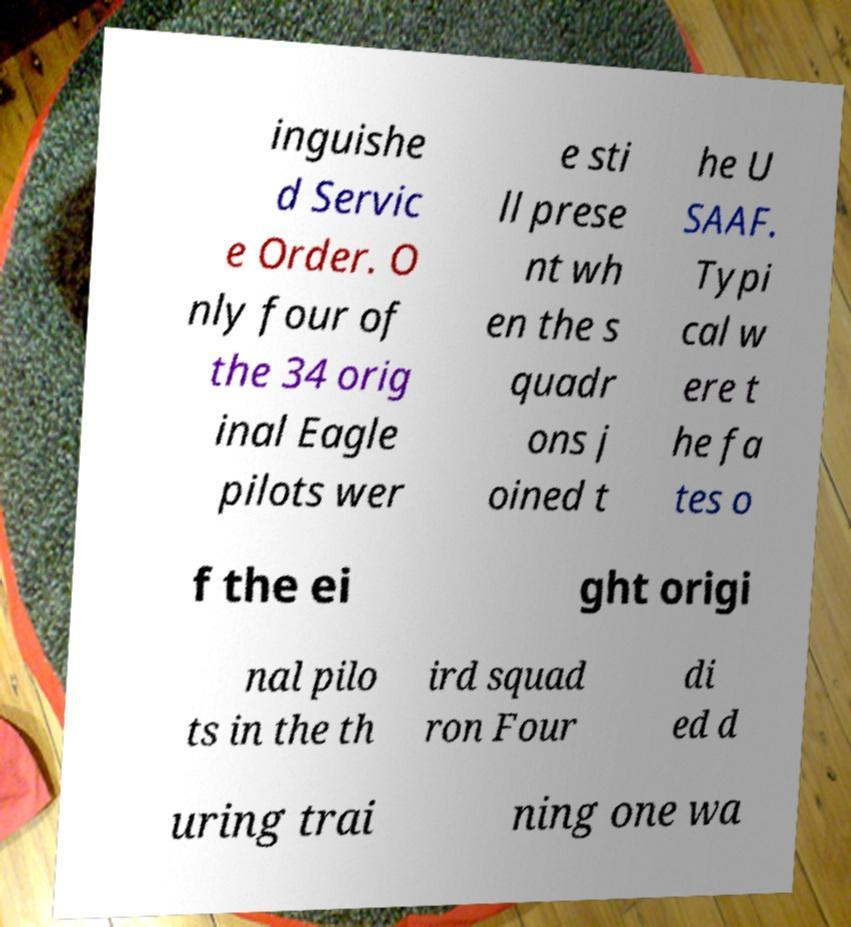Please identify and transcribe the text found in this image. inguishe d Servic e Order. O nly four of the 34 orig inal Eagle pilots wer e sti ll prese nt wh en the s quadr ons j oined t he U SAAF. Typi cal w ere t he fa tes o f the ei ght origi nal pilo ts in the th ird squad ron Four di ed d uring trai ning one wa 